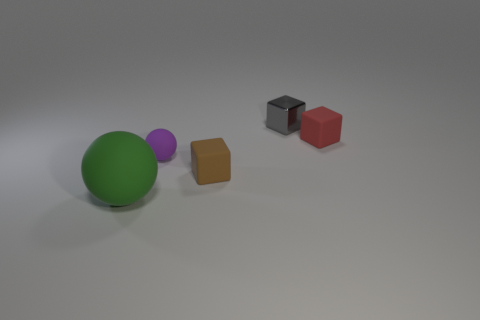What is the shape of the purple object in front of the matte cube that is behind the rubber sphere that is behind the big rubber thing?
Your answer should be very brief. Sphere. Do the cube in front of the purple sphere and the tiny block on the right side of the tiny gray cube have the same material?
Your answer should be compact. Yes. There is a object that is to the left of the small purple matte object; what shape is it?
Provide a succinct answer. Sphere. Are there fewer large blue shiny things than tiny gray cubes?
Offer a very short reply. Yes. There is a sphere in front of the ball behind the green matte ball; is there a tiny gray object that is to the right of it?
Your answer should be compact. Yes. What number of rubber objects are large green spheres or large blue cylinders?
Provide a succinct answer. 1. There is a small sphere; how many small brown matte cubes are left of it?
Offer a terse response. 0. What number of things are in front of the purple sphere and on the left side of the brown rubber object?
Ensure brevity in your answer.  1. The purple thing that is made of the same material as the green sphere is what shape?
Keep it short and to the point. Sphere. There is a rubber ball that is behind the big green thing; is it the same size as the rubber sphere that is left of the purple rubber ball?
Offer a terse response. No. 